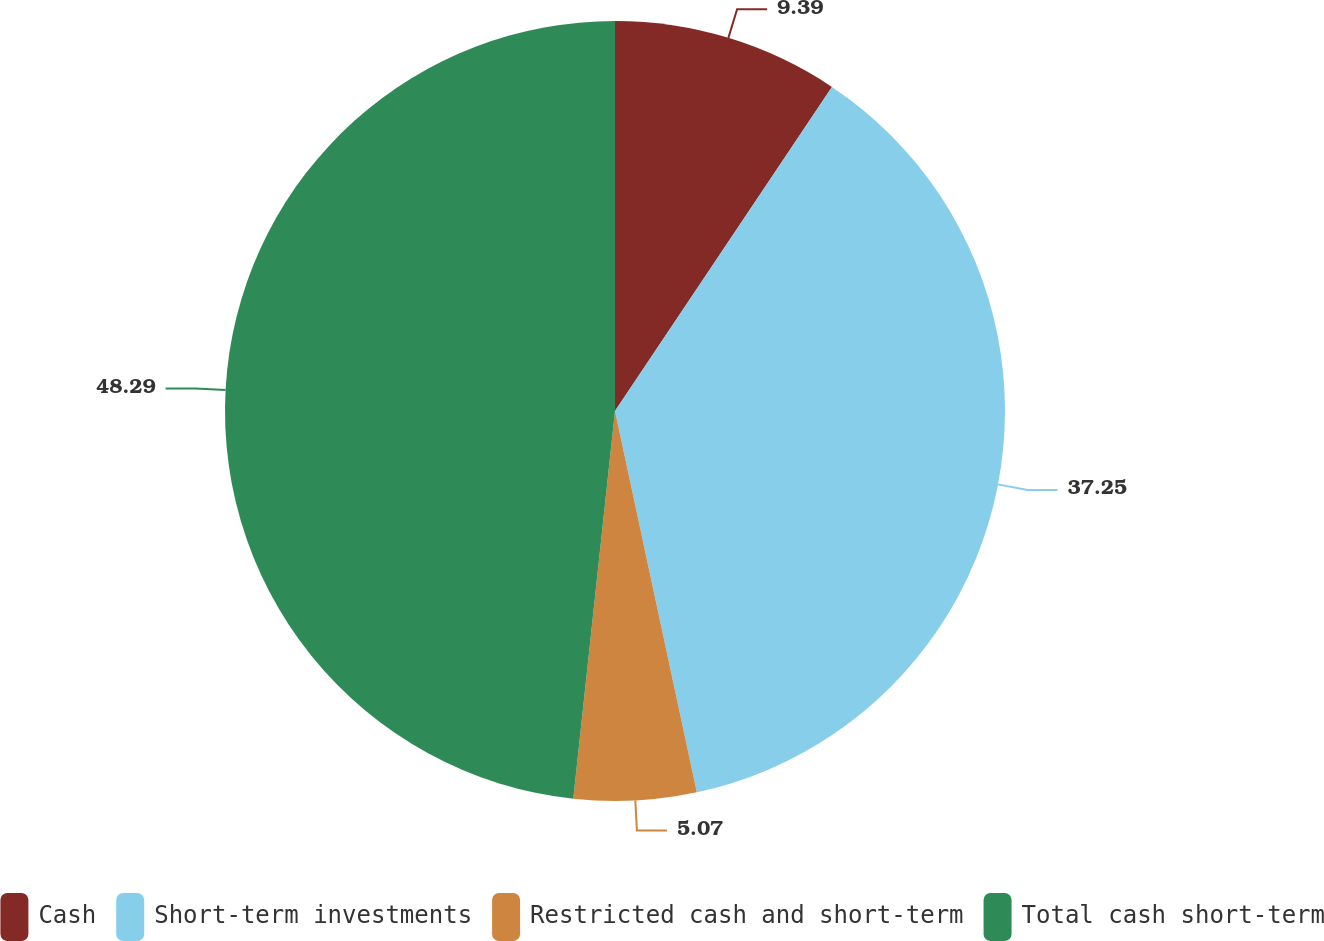Convert chart to OTSL. <chart><loc_0><loc_0><loc_500><loc_500><pie_chart><fcel>Cash<fcel>Short-term investments<fcel>Restricted cash and short-term<fcel>Total cash short-term<nl><fcel>9.39%<fcel>37.25%<fcel>5.07%<fcel>48.3%<nl></chart> 